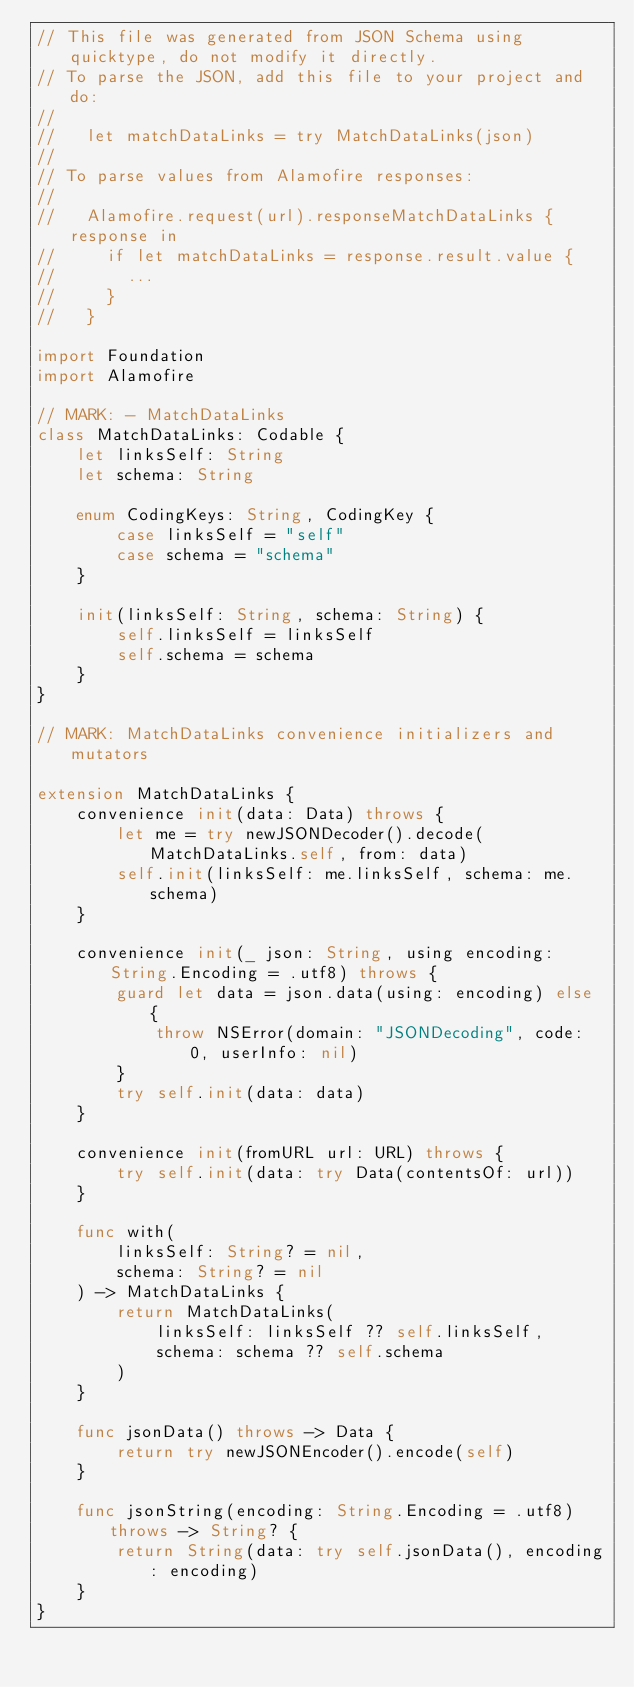Convert code to text. <code><loc_0><loc_0><loc_500><loc_500><_Swift_>// This file was generated from JSON Schema using quicktype, do not modify it directly.
// To parse the JSON, add this file to your project and do:
//
//   let matchDataLinks = try MatchDataLinks(json)
//
// To parse values from Alamofire responses:
//
//   Alamofire.request(url).responseMatchDataLinks { response in
//     if let matchDataLinks = response.result.value {
//       ...
//     }
//   }

import Foundation
import Alamofire

// MARK: - MatchDataLinks
class MatchDataLinks: Codable {
    let linksSelf: String
    let schema: String

    enum CodingKeys: String, CodingKey {
        case linksSelf = "self"
        case schema = "schema"
    }

    init(linksSelf: String, schema: String) {
        self.linksSelf = linksSelf
        self.schema = schema
    }
}

// MARK: MatchDataLinks convenience initializers and mutators

extension MatchDataLinks {
    convenience init(data: Data) throws {
        let me = try newJSONDecoder().decode(MatchDataLinks.self, from: data)
        self.init(linksSelf: me.linksSelf, schema: me.schema)
    }

    convenience init(_ json: String, using encoding: String.Encoding = .utf8) throws {
        guard let data = json.data(using: encoding) else {
            throw NSError(domain: "JSONDecoding", code: 0, userInfo: nil)
        }
        try self.init(data: data)
    }

    convenience init(fromURL url: URL) throws {
        try self.init(data: try Data(contentsOf: url))
    }

    func with(
        linksSelf: String? = nil,
        schema: String? = nil
    ) -> MatchDataLinks {
        return MatchDataLinks(
            linksSelf: linksSelf ?? self.linksSelf,
            schema: schema ?? self.schema
        )
    }

    func jsonData() throws -> Data {
        return try newJSONEncoder().encode(self)
    }

    func jsonString(encoding: String.Encoding = .utf8) throws -> String? {
        return String(data: try self.jsonData(), encoding: encoding)
    }
}
</code> 